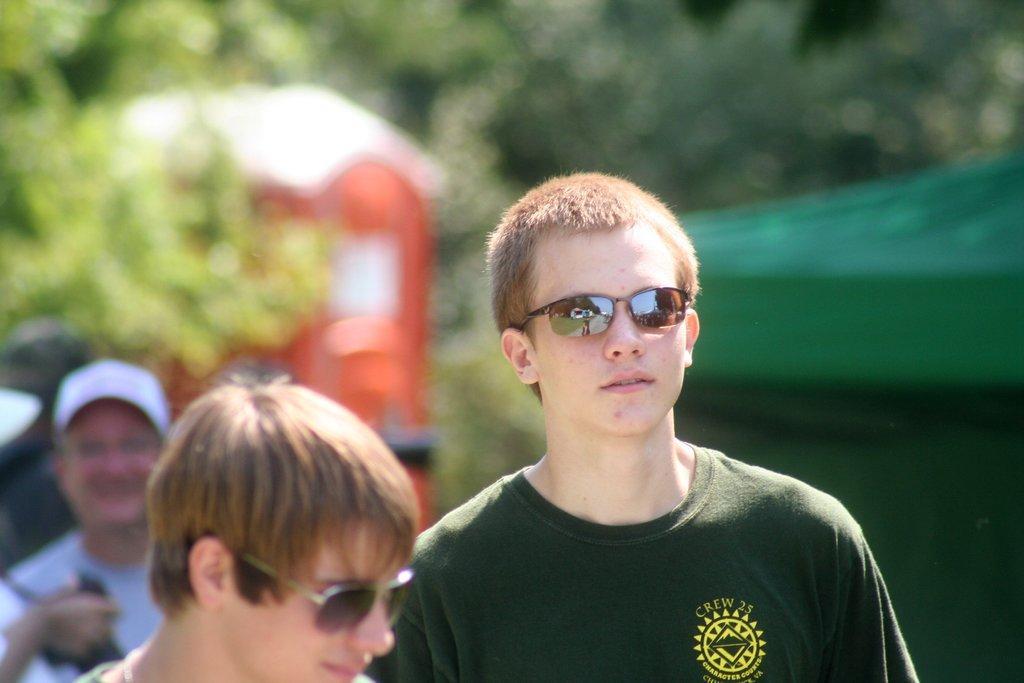In one or two sentences, can you explain what this image depicts? In this picture we can observe two men wearing spectacles. We can observe a green color T shirt. In the background there is another person standing, wearing white color cap on his head. There are trees in the background. 